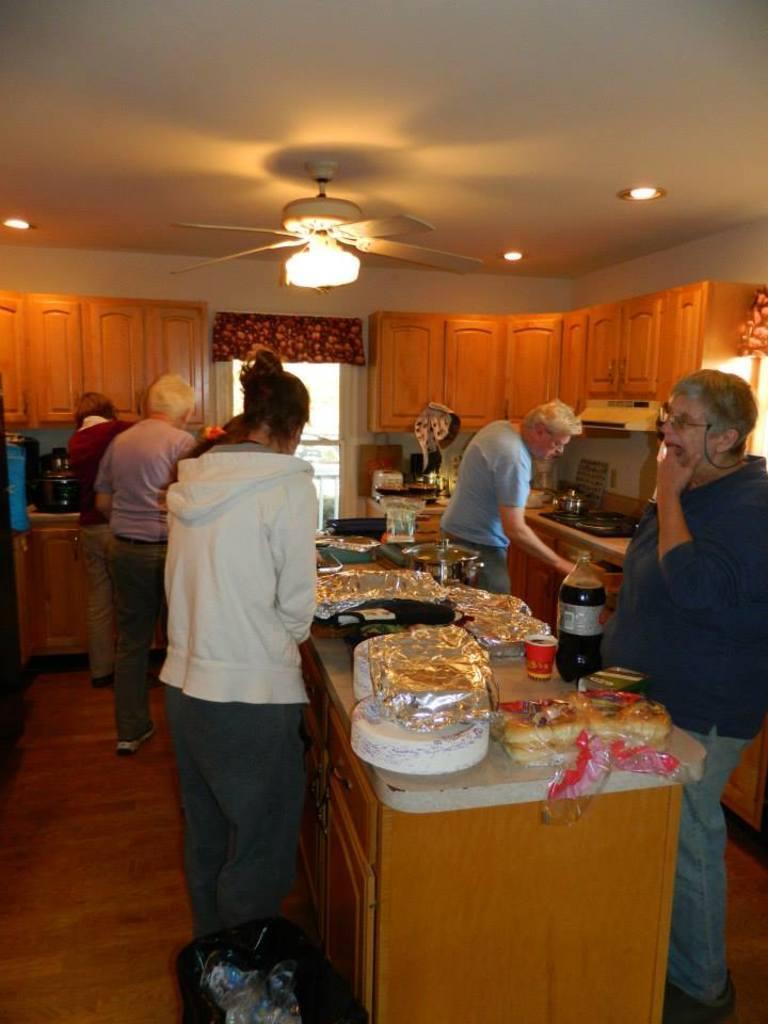Describe this image in one or two sentences. These persons are standing. We can see covers,plates,food,bottle on the table. On the background we can see wall,cupboards,glass window. On the top we can see lights. We can see bin on the floor. 